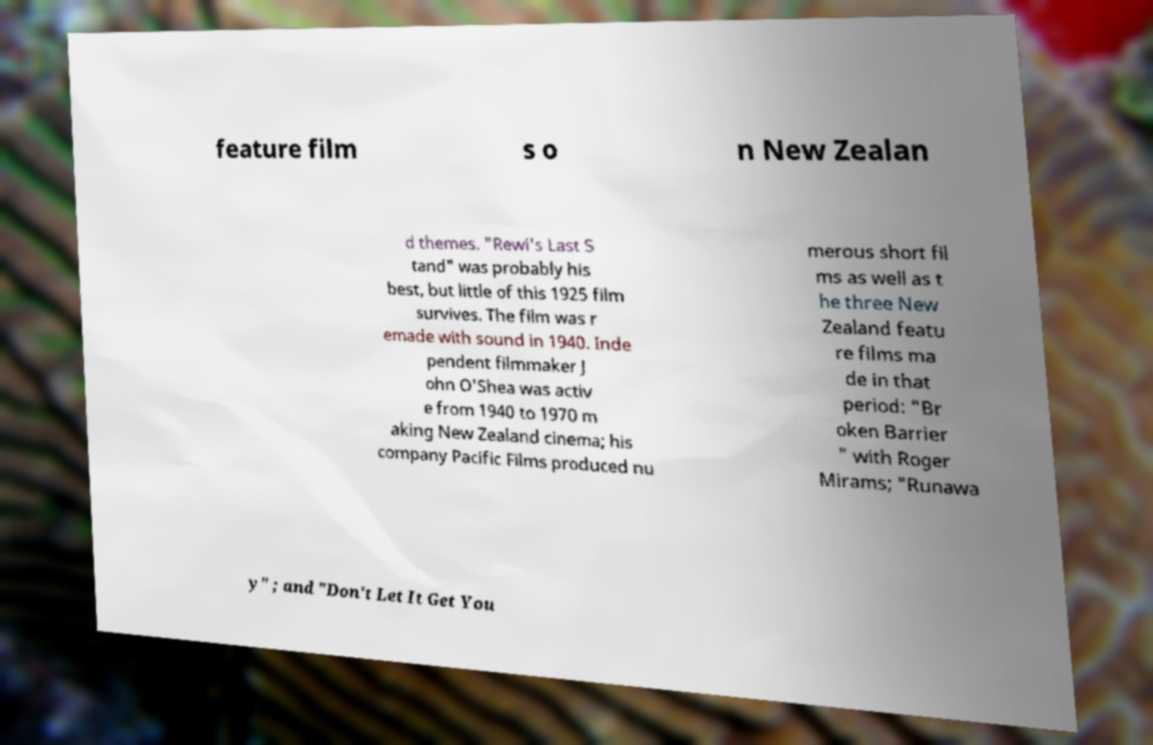Can you accurately transcribe the text from the provided image for me? feature film s o n New Zealan d themes. "Rewi's Last S tand" was probably his best, but little of this 1925 film survives. The film was r emade with sound in 1940. Inde pendent filmmaker J ohn O'Shea was activ e from 1940 to 1970 m aking New Zealand cinema; his company Pacific Films produced nu merous short fil ms as well as t he three New Zealand featu re films ma de in that period: "Br oken Barrier " with Roger Mirams; "Runawa y" ; and "Don't Let It Get You 